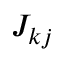<formula> <loc_0><loc_0><loc_500><loc_500>J _ { k j }</formula> 